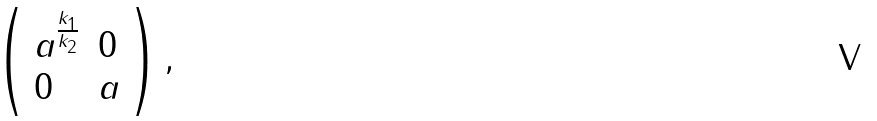<formula> <loc_0><loc_0><loc_500><loc_500>\left ( \begin{array} { l l } a ^ { \frac { k _ { 1 } } { k _ { 2 } } } & 0 \\ 0 & a \end{array} \right ) ,</formula> 